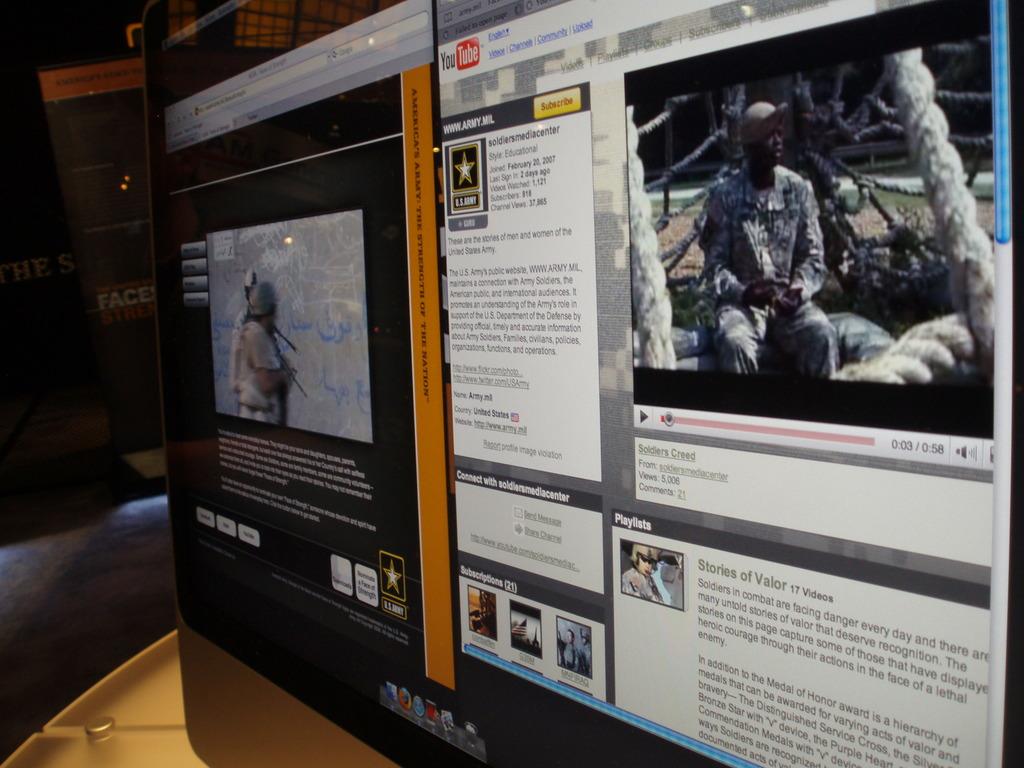Can you be able read this article?
Offer a terse response. Yes. What is the title of the youtube video?
Provide a succinct answer. Soldiers creed. 